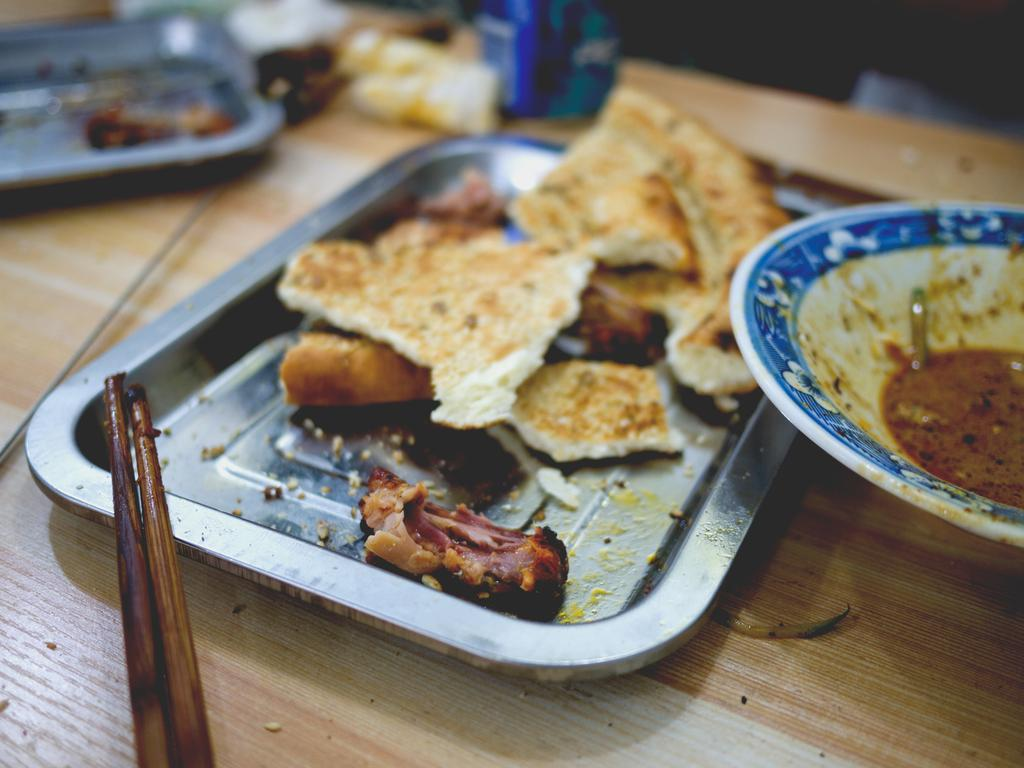What type of items can be seen in the image? There are food items in the image. How are the food items arranged? The food items are in different places. What is used to serve the food items? There are plates in the image. What is the material of the surface where the plates are placed? The plates are placed on a wooden surface. Can you describe the object on the left side of the image? There is an object on the left side of the image, but the facts do not provide any details about it. How many men are visible in the image? There are no men present in the image. What type of worm can be seen crawling on the food items? There are no worms present in the image. 